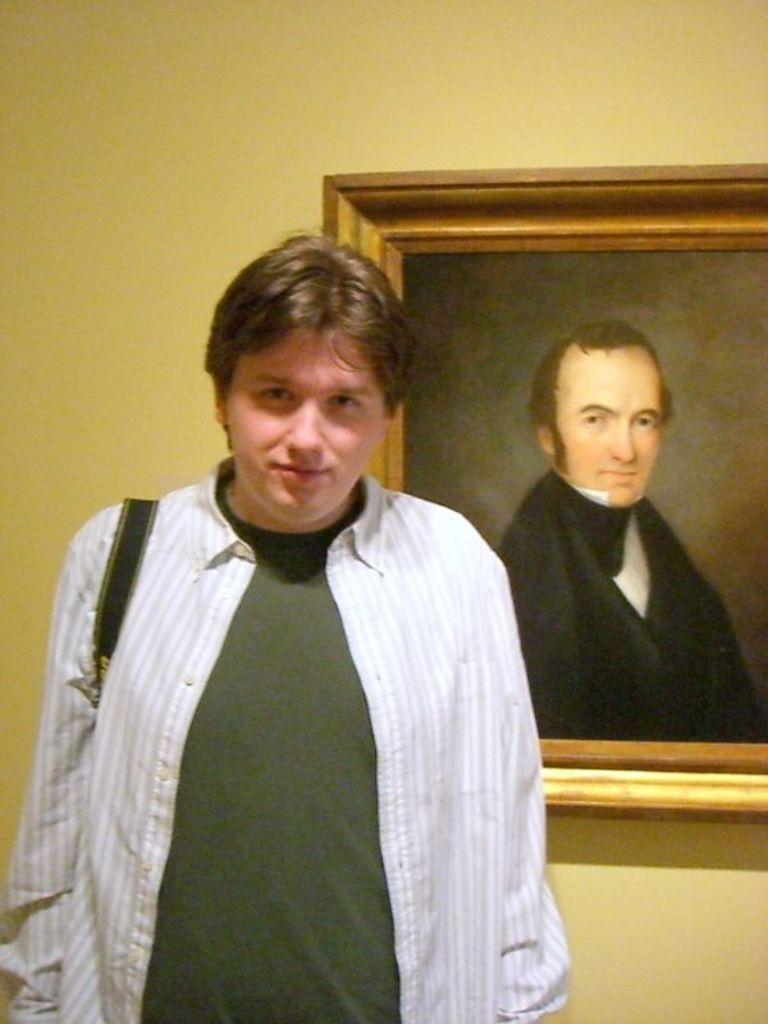What is the main subject in the foreground of the image? There is a person in the foreground of the image. What is the person doing in the image? The person is standing. What can be seen on the right side of the image? There is a frame attached to the wall on the right side of the image. What is visible in the background of the image? There is a wall in the background of the image. How many frogs are sitting on the wall in the image? There are no frogs present in the image; it only features a person standing and a frame on the wall. 